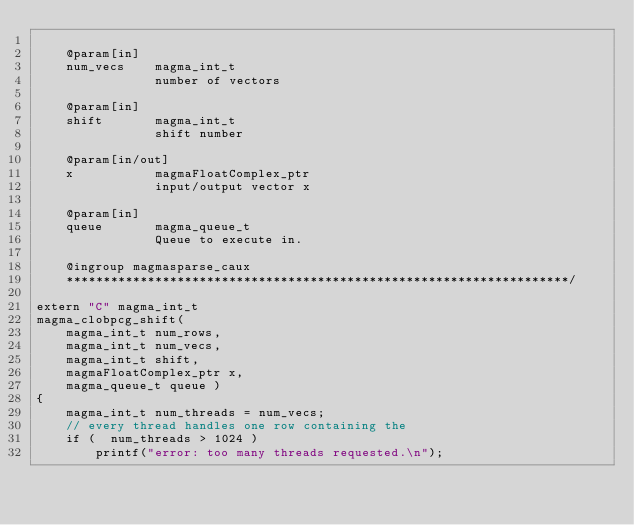Convert code to text. <code><loc_0><loc_0><loc_500><loc_500><_Cuda_>
    @param[in]
    num_vecs    magma_int_t
                number of vectors

    @param[in]
    shift       magma_int_t
                shift number

    @param[in/out]
    x           magmaFloatComplex_ptr 
                input/output vector x

    @param[in]
    queue       magma_queue_t
                Queue to execute in.

    @ingroup magmasparse_caux
    ********************************************************************/

extern "C" magma_int_t
magma_clobpcg_shift(
    magma_int_t num_rows,
    magma_int_t num_vecs, 
    magma_int_t shift,
    magmaFloatComplex_ptr x,
    magma_queue_t queue )
{
    magma_int_t num_threads = num_vecs;
    // every thread handles one row containing the 
    if (  num_threads > 1024 )
        printf("error: too many threads requested.\n");
</code> 